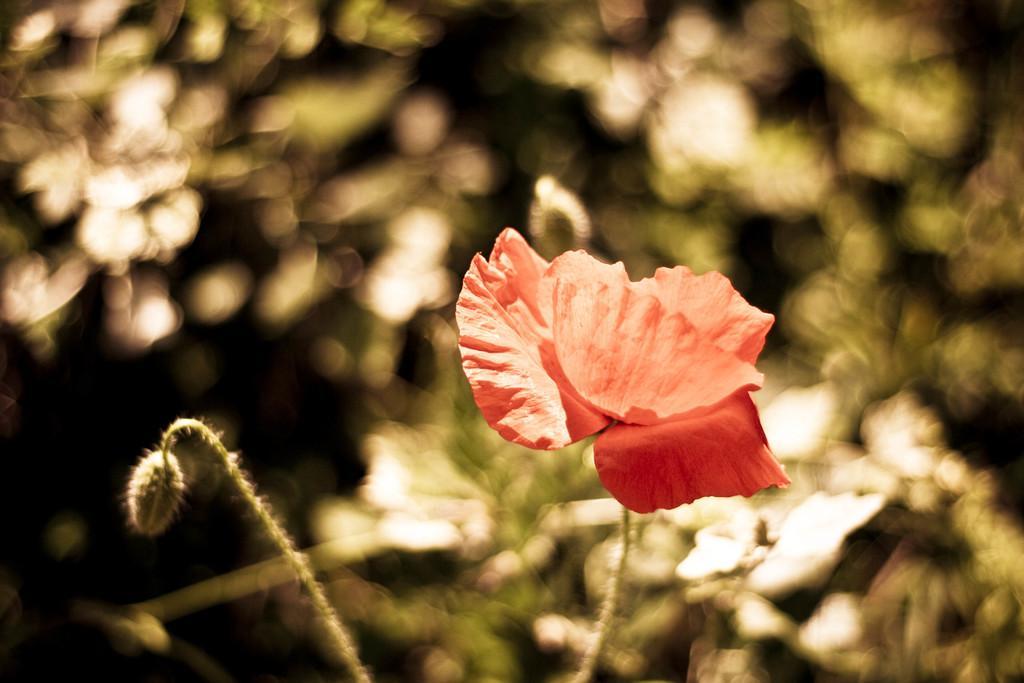Please provide a concise description of this image. In this image we can see a red color flower, beside there is a bud, there are trees, there it is blurry. 